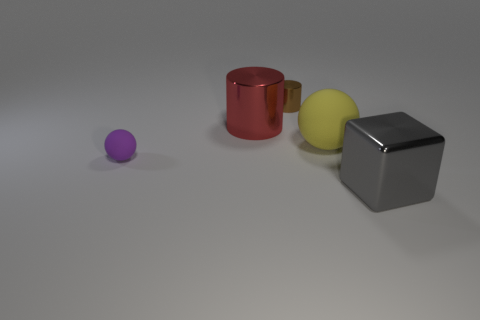Does the large metal object in front of the purple thing have the same shape as the large red object?
Provide a succinct answer. No. What number of things are rubber objects left of the tiny brown metal cylinder or big matte objects?
Make the answer very short. 2. Is there a small red object of the same shape as the gray object?
Your answer should be very brief. No. There is a yellow object that is the same size as the cube; what is its shape?
Give a very brief answer. Sphere. There is a object that is in front of the sphere that is in front of the matte object that is on the right side of the tiny metal cylinder; what shape is it?
Give a very brief answer. Cube. There is a brown shiny thing; is it the same shape as the shiny thing in front of the big yellow matte sphere?
Give a very brief answer. No. What number of tiny objects are either red objects or green blocks?
Ensure brevity in your answer.  0. Is there a cylinder that has the same size as the yellow matte object?
Provide a succinct answer. Yes. There is a large shiny object left of the shiny object that is right of the small object to the right of the small rubber object; what color is it?
Give a very brief answer. Red. Is the material of the brown cylinder the same as the tiny object that is in front of the tiny brown cylinder?
Your answer should be compact. No. 